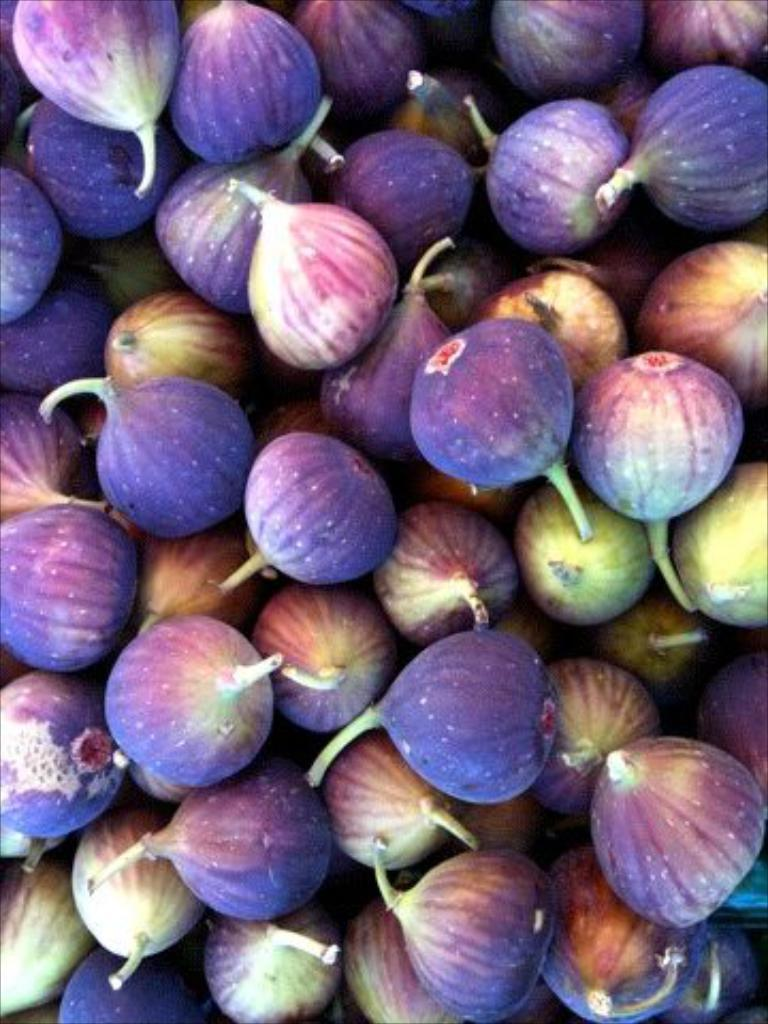What type of food can be seen in the image? There are fruits in the image. What color are the fruits in the image? The fruits are in brinjal color. What type of stitch is used to sew the request in the image? There is no stitch or request present in the image; it features fruits in brinjal color. 